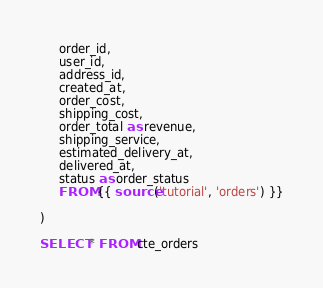<code> <loc_0><loc_0><loc_500><loc_500><_SQL_>     order_id,
     user_id,
     address_id,
     created_at,
     order_cost,
     shipping_cost,
     order_total as revenue,
     shipping_service,
     estimated_delivery_at,
     delivered_at,
     status as order_status 
     FROM {{ source('tutorial', 'orders') }}

)

SELECT * FROM cte_orders</code> 